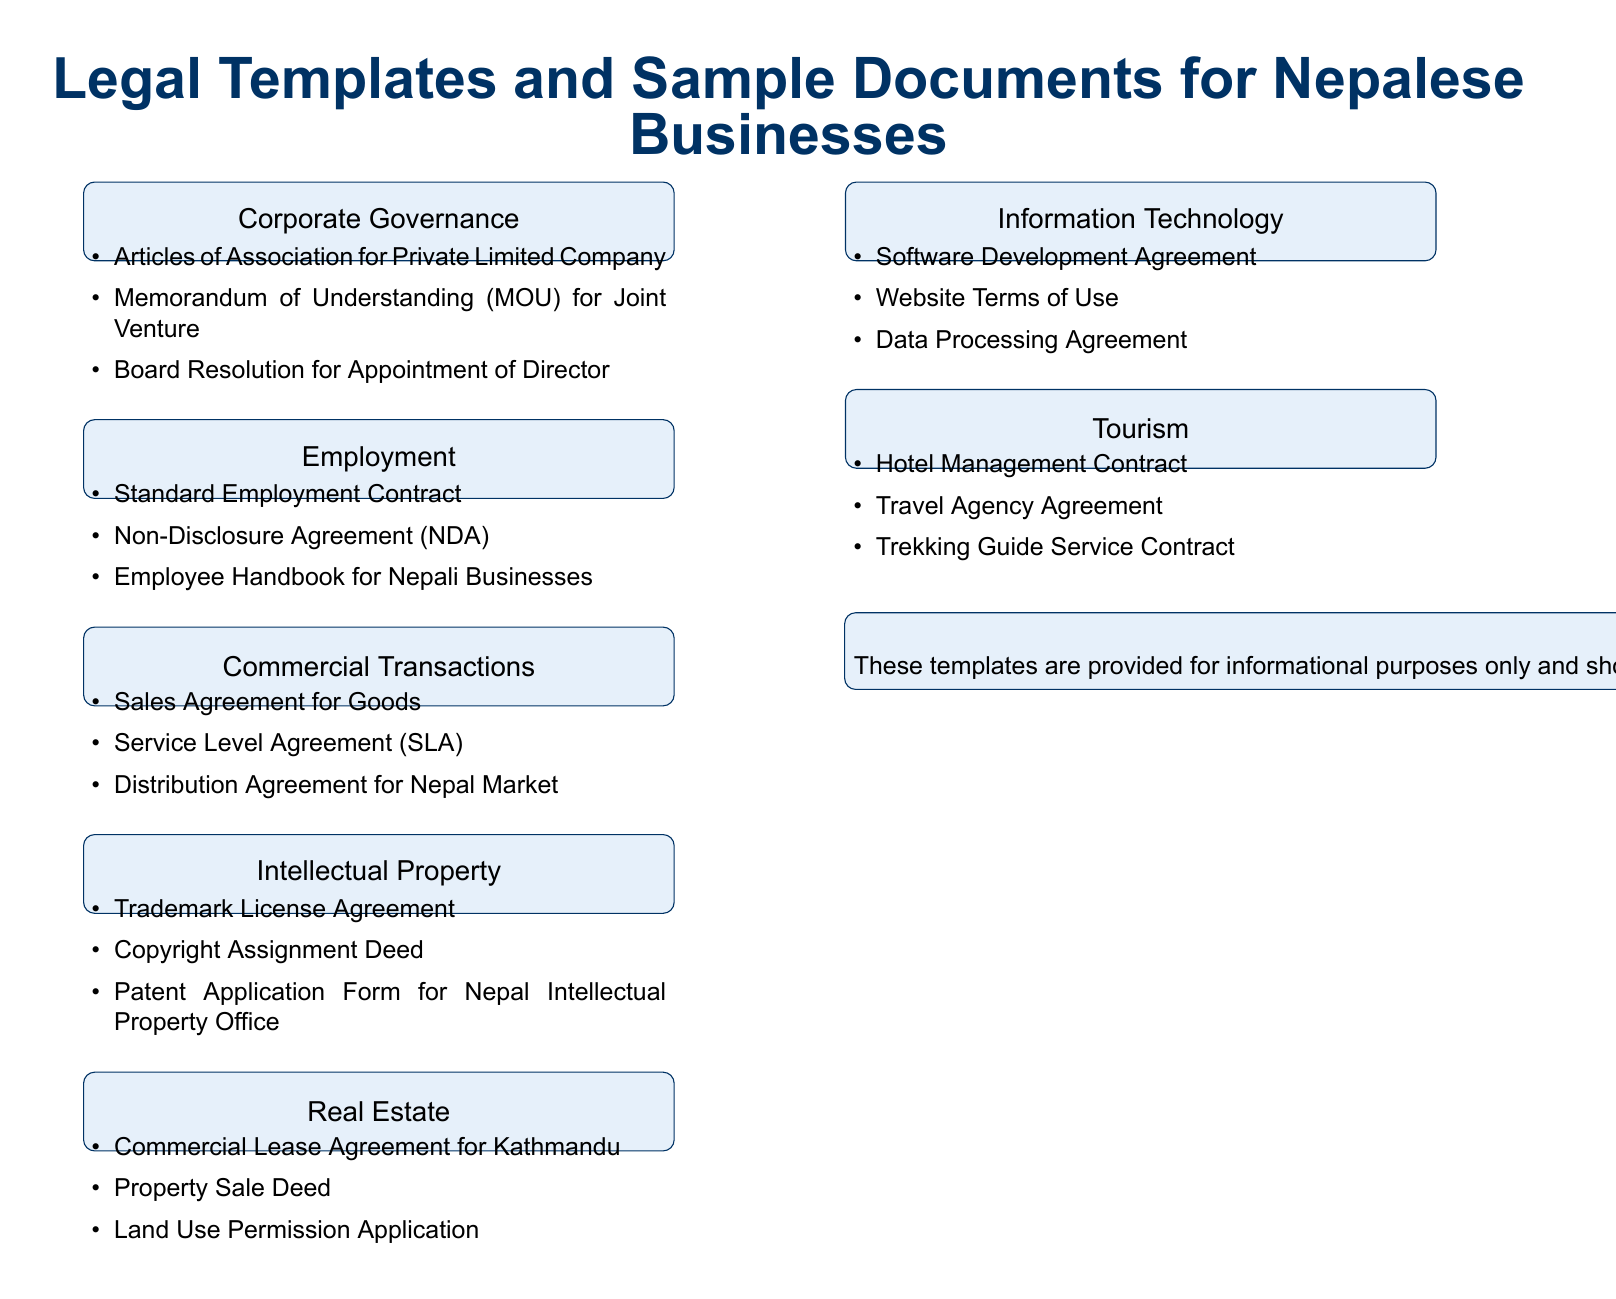What is the first category listed in the document? The first category is Corporate Governance, as shown in the provided document.
Answer: Corporate Governance How many document types are listed under Employment? There are three document types listed under Employment in the document.
Answer: Three Which agreement is specifically related to the technology sector? The document mentions a Software Development Agreement under the Information Technology category.
Answer: Software Development Agreement What is the legal disclaimer about? The legal disclaimer states that templates should be reviewed by a qualified legal professional and mentions possible changes in laws and regulations.
Answer: Informational purposes How many categories are represented in the document? The document contains seven distinct categories for legal templates and sample documents.
Answer: Seven Which type of agreement is used for the tourism industry according to the document? The document includes a Hotel Management Contract as a type of agreement in the Tourism category.
Answer: Hotel Management Contract What document relates to land management? The Land Use Permission Application is mentioned as relating to land management in the Real Estate category.
Answer: Land Use Permission Application What should be done before using the templates? The disclaimer advises that the templates should be reviewed by a qualified legal professional before use.
Answer: Reviewed by a qualified legal professional 